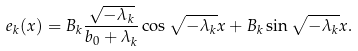<formula> <loc_0><loc_0><loc_500><loc_500>e _ { k } ( x ) = B _ { k } \frac { \sqrt { - \lambda _ { k } } } { b _ { 0 } + \lambda _ { k } } \cos \sqrt { - \lambda _ { k } } x + B _ { k } \sin \sqrt { - \lambda _ { k } } x .</formula> 